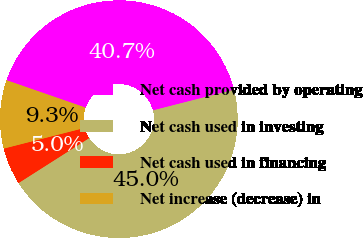Convert chart. <chart><loc_0><loc_0><loc_500><loc_500><pie_chart><fcel>Net cash provided by operating<fcel>Net cash used in investing<fcel>Net cash used in financing<fcel>Net increase (decrease) in<nl><fcel>40.71%<fcel>44.96%<fcel>5.04%<fcel>9.29%<nl></chart> 